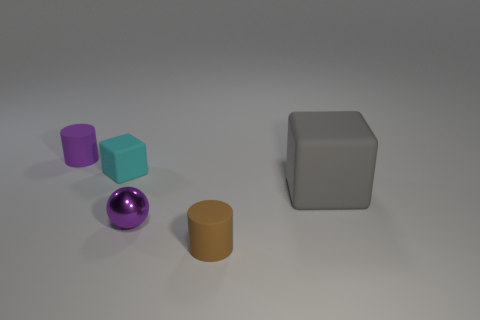Add 1 tiny brown rubber balls. How many objects exist? 6 Subtract all brown cylinders. How many cylinders are left? 1 Subtract all brown cylinders. Subtract all brown cubes. How many cylinders are left? 1 Subtract all yellow cubes. How many brown cylinders are left? 1 Subtract all small matte things. Subtract all big blocks. How many objects are left? 1 Add 5 brown cylinders. How many brown cylinders are left? 6 Add 5 balls. How many balls exist? 6 Subtract 0 yellow balls. How many objects are left? 5 Subtract all cubes. How many objects are left? 3 Subtract 1 balls. How many balls are left? 0 